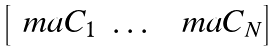<formula> <loc_0><loc_0><loc_500><loc_500>\begin{bmatrix} \ m a { C } _ { 1 } & \dots & \ m a { C } _ { N } \end{bmatrix}</formula> 